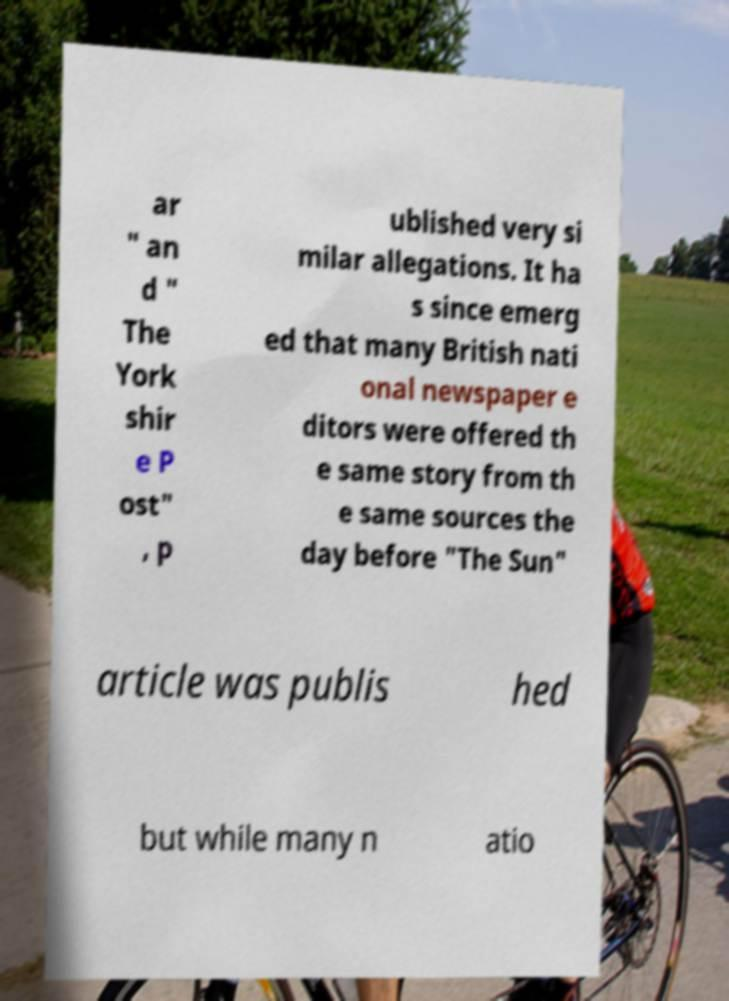Can you accurately transcribe the text from the provided image for me? ar " an d " The York shir e P ost" , p ublished very si milar allegations. It ha s since emerg ed that many British nati onal newspaper e ditors were offered th e same story from th e same sources the day before "The Sun" article was publis hed but while many n atio 